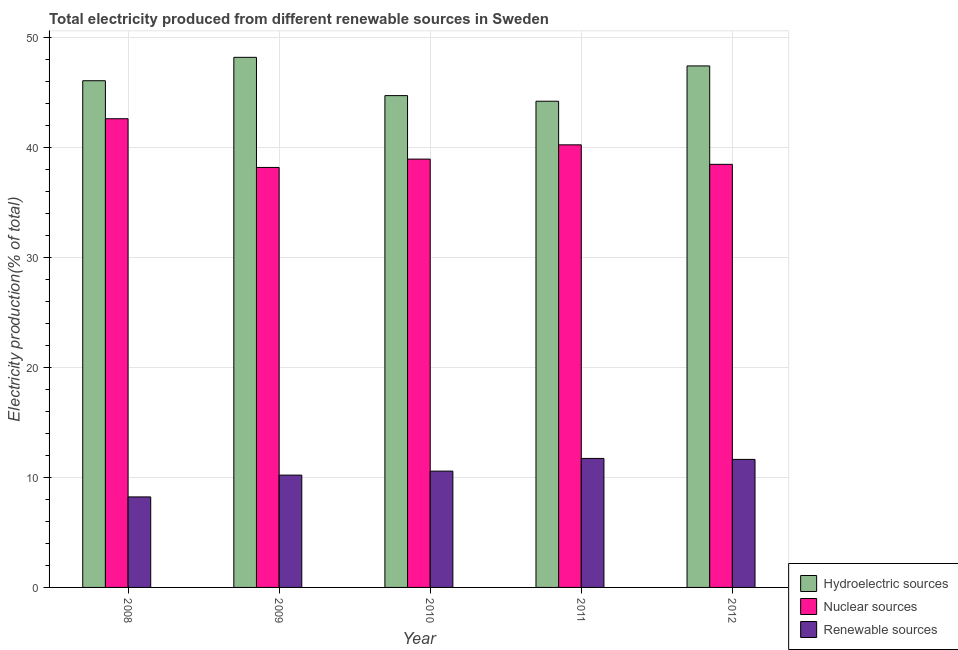Are the number of bars on each tick of the X-axis equal?
Give a very brief answer. Yes. How many bars are there on the 4th tick from the right?
Your answer should be compact. 3. What is the percentage of electricity produced by renewable sources in 2009?
Ensure brevity in your answer.  10.21. Across all years, what is the maximum percentage of electricity produced by hydroelectric sources?
Offer a terse response. 48.21. Across all years, what is the minimum percentage of electricity produced by hydroelectric sources?
Your answer should be very brief. 44.21. In which year was the percentage of electricity produced by renewable sources minimum?
Provide a succinct answer. 2008. What is the total percentage of electricity produced by nuclear sources in the graph?
Your response must be concise. 198.49. What is the difference between the percentage of electricity produced by hydroelectric sources in 2008 and that in 2010?
Provide a succinct answer. 1.35. What is the difference between the percentage of electricity produced by nuclear sources in 2010 and the percentage of electricity produced by hydroelectric sources in 2012?
Give a very brief answer. 0.48. What is the average percentage of electricity produced by renewable sources per year?
Make the answer very short. 10.48. In the year 2011, what is the difference between the percentage of electricity produced by nuclear sources and percentage of electricity produced by renewable sources?
Your answer should be very brief. 0. What is the ratio of the percentage of electricity produced by renewable sources in 2009 to that in 2011?
Offer a terse response. 0.87. What is the difference between the highest and the second highest percentage of electricity produced by hydroelectric sources?
Give a very brief answer. 0.78. What is the difference between the highest and the lowest percentage of electricity produced by renewable sources?
Offer a very short reply. 3.5. In how many years, is the percentage of electricity produced by hydroelectric sources greater than the average percentage of electricity produced by hydroelectric sources taken over all years?
Make the answer very short. 2. Is the sum of the percentage of electricity produced by nuclear sources in 2009 and 2010 greater than the maximum percentage of electricity produced by hydroelectric sources across all years?
Make the answer very short. Yes. What does the 1st bar from the left in 2010 represents?
Your response must be concise. Hydroelectric sources. What does the 2nd bar from the right in 2009 represents?
Your answer should be compact. Nuclear sources. Is it the case that in every year, the sum of the percentage of electricity produced by hydroelectric sources and percentage of electricity produced by nuclear sources is greater than the percentage of electricity produced by renewable sources?
Your answer should be very brief. Yes. Are all the bars in the graph horizontal?
Provide a succinct answer. No. How many years are there in the graph?
Offer a terse response. 5. What is the difference between two consecutive major ticks on the Y-axis?
Offer a very short reply. 10. Are the values on the major ticks of Y-axis written in scientific E-notation?
Offer a very short reply. No. Does the graph contain any zero values?
Provide a short and direct response. No. Where does the legend appear in the graph?
Your answer should be compact. Bottom right. How are the legend labels stacked?
Offer a very short reply. Vertical. What is the title of the graph?
Offer a very short reply. Total electricity produced from different renewable sources in Sweden. Does "Refusal of sex" appear as one of the legend labels in the graph?
Offer a very short reply. No. What is the label or title of the Y-axis?
Provide a short and direct response. Electricity production(% of total). What is the Electricity production(% of total) of Hydroelectric sources in 2008?
Ensure brevity in your answer.  46.08. What is the Electricity production(% of total) of Nuclear sources in 2008?
Provide a short and direct response. 42.62. What is the Electricity production(% of total) of Renewable sources in 2008?
Provide a succinct answer. 8.23. What is the Electricity production(% of total) in Hydroelectric sources in 2009?
Your answer should be compact. 48.21. What is the Electricity production(% of total) of Nuclear sources in 2009?
Give a very brief answer. 38.19. What is the Electricity production(% of total) in Renewable sources in 2009?
Give a very brief answer. 10.21. What is the Electricity production(% of total) of Hydroelectric sources in 2010?
Your response must be concise. 44.72. What is the Electricity production(% of total) in Nuclear sources in 2010?
Provide a succinct answer. 38.95. What is the Electricity production(% of total) in Renewable sources in 2010?
Your response must be concise. 10.58. What is the Electricity production(% of total) of Hydroelectric sources in 2011?
Give a very brief answer. 44.21. What is the Electricity production(% of total) of Nuclear sources in 2011?
Make the answer very short. 40.25. What is the Electricity production(% of total) in Renewable sources in 2011?
Ensure brevity in your answer.  11.73. What is the Electricity production(% of total) in Hydroelectric sources in 2012?
Offer a terse response. 47.42. What is the Electricity production(% of total) in Nuclear sources in 2012?
Ensure brevity in your answer.  38.48. What is the Electricity production(% of total) of Renewable sources in 2012?
Ensure brevity in your answer.  11.64. Across all years, what is the maximum Electricity production(% of total) of Hydroelectric sources?
Keep it short and to the point. 48.21. Across all years, what is the maximum Electricity production(% of total) of Nuclear sources?
Ensure brevity in your answer.  42.62. Across all years, what is the maximum Electricity production(% of total) in Renewable sources?
Your answer should be very brief. 11.73. Across all years, what is the minimum Electricity production(% of total) in Hydroelectric sources?
Provide a succinct answer. 44.21. Across all years, what is the minimum Electricity production(% of total) in Nuclear sources?
Provide a short and direct response. 38.19. Across all years, what is the minimum Electricity production(% of total) of Renewable sources?
Provide a succinct answer. 8.23. What is the total Electricity production(% of total) of Hydroelectric sources in the graph?
Ensure brevity in your answer.  230.65. What is the total Electricity production(% of total) in Nuclear sources in the graph?
Keep it short and to the point. 198.49. What is the total Electricity production(% of total) of Renewable sources in the graph?
Your response must be concise. 52.39. What is the difference between the Electricity production(% of total) of Hydroelectric sources in 2008 and that in 2009?
Your answer should be very brief. -2.13. What is the difference between the Electricity production(% of total) of Nuclear sources in 2008 and that in 2009?
Ensure brevity in your answer.  4.43. What is the difference between the Electricity production(% of total) in Renewable sources in 2008 and that in 2009?
Provide a short and direct response. -1.98. What is the difference between the Electricity production(% of total) of Hydroelectric sources in 2008 and that in 2010?
Your answer should be compact. 1.35. What is the difference between the Electricity production(% of total) of Nuclear sources in 2008 and that in 2010?
Your answer should be very brief. 3.67. What is the difference between the Electricity production(% of total) in Renewable sources in 2008 and that in 2010?
Give a very brief answer. -2.35. What is the difference between the Electricity production(% of total) of Hydroelectric sources in 2008 and that in 2011?
Your response must be concise. 1.86. What is the difference between the Electricity production(% of total) in Nuclear sources in 2008 and that in 2011?
Provide a succinct answer. 2.37. What is the difference between the Electricity production(% of total) in Renewable sources in 2008 and that in 2011?
Your answer should be compact. -3.5. What is the difference between the Electricity production(% of total) of Hydroelectric sources in 2008 and that in 2012?
Provide a short and direct response. -1.35. What is the difference between the Electricity production(% of total) in Nuclear sources in 2008 and that in 2012?
Your answer should be compact. 4.15. What is the difference between the Electricity production(% of total) of Renewable sources in 2008 and that in 2012?
Ensure brevity in your answer.  -3.41. What is the difference between the Electricity production(% of total) in Hydroelectric sources in 2009 and that in 2010?
Provide a short and direct response. 3.48. What is the difference between the Electricity production(% of total) in Nuclear sources in 2009 and that in 2010?
Your answer should be compact. -0.76. What is the difference between the Electricity production(% of total) in Renewable sources in 2009 and that in 2010?
Offer a very short reply. -0.36. What is the difference between the Electricity production(% of total) of Hydroelectric sources in 2009 and that in 2011?
Provide a short and direct response. 3.99. What is the difference between the Electricity production(% of total) in Nuclear sources in 2009 and that in 2011?
Ensure brevity in your answer.  -2.06. What is the difference between the Electricity production(% of total) of Renewable sources in 2009 and that in 2011?
Ensure brevity in your answer.  -1.52. What is the difference between the Electricity production(% of total) of Hydroelectric sources in 2009 and that in 2012?
Provide a short and direct response. 0.78. What is the difference between the Electricity production(% of total) in Nuclear sources in 2009 and that in 2012?
Your response must be concise. -0.28. What is the difference between the Electricity production(% of total) of Renewable sources in 2009 and that in 2012?
Your answer should be compact. -1.43. What is the difference between the Electricity production(% of total) in Hydroelectric sources in 2010 and that in 2011?
Keep it short and to the point. 0.51. What is the difference between the Electricity production(% of total) in Nuclear sources in 2010 and that in 2011?
Your response must be concise. -1.3. What is the difference between the Electricity production(% of total) in Renewable sources in 2010 and that in 2011?
Make the answer very short. -1.15. What is the difference between the Electricity production(% of total) of Hydroelectric sources in 2010 and that in 2012?
Ensure brevity in your answer.  -2.7. What is the difference between the Electricity production(% of total) in Nuclear sources in 2010 and that in 2012?
Keep it short and to the point. 0.48. What is the difference between the Electricity production(% of total) of Renewable sources in 2010 and that in 2012?
Your answer should be very brief. -1.07. What is the difference between the Electricity production(% of total) of Hydroelectric sources in 2011 and that in 2012?
Provide a short and direct response. -3.21. What is the difference between the Electricity production(% of total) of Nuclear sources in 2011 and that in 2012?
Offer a terse response. 1.77. What is the difference between the Electricity production(% of total) in Renewable sources in 2011 and that in 2012?
Offer a very short reply. 0.09. What is the difference between the Electricity production(% of total) of Hydroelectric sources in 2008 and the Electricity production(% of total) of Nuclear sources in 2009?
Provide a short and direct response. 7.89. What is the difference between the Electricity production(% of total) of Hydroelectric sources in 2008 and the Electricity production(% of total) of Renewable sources in 2009?
Provide a succinct answer. 35.87. What is the difference between the Electricity production(% of total) in Nuclear sources in 2008 and the Electricity production(% of total) in Renewable sources in 2009?
Make the answer very short. 32.41. What is the difference between the Electricity production(% of total) of Hydroelectric sources in 2008 and the Electricity production(% of total) of Nuclear sources in 2010?
Offer a very short reply. 7.13. What is the difference between the Electricity production(% of total) of Hydroelectric sources in 2008 and the Electricity production(% of total) of Renewable sources in 2010?
Offer a terse response. 35.5. What is the difference between the Electricity production(% of total) in Nuclear sources in 2008 and the Electricity production(% of total) in Renewable sources in 2010?
Ensure brevity in your answer.  32.05. What is the difference between the Electricity production(% of total) of Hydroelectric sources in 2008 and the Electricity production(% of total) of Nuclear sources in 2011?
Keep it short and to the point. 5.83. What is the difference between the Electricity production(% of total) of Hydroelectric sources in 2008 and the Electricity production(% of total) of Renewable sources in 2011?
Offer a very short reply. 34.35. What is the difference between the Electricity production(% of total) of Nuclear sources in 2008 and the Electricity production(% of total) of Renewable sources in 2011?
Offer a very short reply. 30.89. What is the difference between the Electricity production(% of total) of Hydroelectric sources in 2008 and the Electricity production(% of total) of Nuclear sources in 2012?
Your answer should be compact. 7.6. What is the difference between the Electricity production(% of total) of Hydroelectric sources in 2008 and the Electricity production(% of total) of Renewable sources in 2012?
Provide a succinct answer. 34.44. What is the difference between the Electricity production(% of total) in Nuclear sources in 2008 and the Electricity production(% of total) in Renewable sources in 2012?
Your answer should be compact. 30.98. What is the difference between the Electricity production(% of total) of Hydroelectric sources in 2009 and the Electricity production(% of total) of Nuclear sources in 2010?
Your answer should be compact. 9.25. What is the difference between the Electricity production(% of total) of Hydroelectric sources in 2009 and the Electricity production(% of total) of Renewable sources in 2010?
Ensure brevity in your answer.  37.63. What is the difference between the Electricity production(% of total) of Nuclear sources in 2009 and the Electricity production(% of total) of Renewable sources in 2010?
Offer a very short reply. 27.62. What is the difference between the Electricity production(% of total) of Hydroelectric sources in 2009 and the Electricity production(% of total) of Nuclear sources in 2011?
Your answer should be compact. 7.96. What is the difference between the Electricity production(% of total) in Hydroelectric sources in 2009 and the Electricity production(% of total) in Renewable sources in 2011?
Offer a very short reply. 36.48. What is the difference between the Electricity production(% of total) of Nuclear sources in 2009 and the Electricity production(% of total) of Renewable sources in 2011?
Provide a short and direct response. 26.46. What is the difference between the Electricity production(% of total) in Hydroelectric sources in 2009 and the Electricity production(% of total) in Nuclear sources in 2012?
Keep it short and to the point. 9.73. What is the difference between the Electricity production(% of total) in Hydroelectric sources in 2009 and the Electricity production(% of total) in Renewable sources in 2012?
Offer a terse response. 36.56. What is the difference between the Electricity production(% of total) in Nuclear sources in 2009 and the Electricity production(% of total) in Renewable sources in 2012?
Provide a succinct answer. 26.55. What is the difference between the Electricity production(% of total) in Hydroelectric sources in 2010 and the Electricity production(% of total) in Nuclear sources in 2011?
Keep it short and to the point. 4.48. What is the difference between the Electricity production(% of total) of Hydroelectric sources in 2010 and the Electricity production(% of total) of Renewable sources in 2011?
Provide a short and direct response. 32.99. What is the difference between the Electricity production(% of total) in Nuclear sources in 2010 and the Electricity production(% of total) in Renewable sources in 2011?
Keep it short and to the point. 27.22. What is the difference between the Electricity production(% of total) of Hydroelectric sources in 2010 and the Electricity production(% of total) of Nuclear sources in 2012?
Provide a short and direct response. 6.25. What is the difference between the Electricity production(% of total) in Hydroelectric sources in 2010 and the Electricity production(% of total) in Renewable sources in 2012?
Provide a short and direct response. 33.08. What is the difference between the Electricity production(% of total) in Nuclear sources in 2010 and the Electricity production(% of total) in Renewable sources in 2012?
Your response must be concise. 27.31. What is the difference between the Electricity production(% of total) of Hydroelectric sources in 2011 and the Electricity production(% of total) of Nuclear sources in 2012?
Make the answer very short. 5.74. What is the difference between the Electricity production(% of total) in Hydroelectric sources in 2011 and the Electricity production(% of total) in Renewable sources in 2012?
Your answer should be very brief. 32.57. What is the difference between the Electricity production(% of total) of Nuclear sources in 2011 and the Electricity production(% of total) of Renewable sources in 2012?
Make the answer very short. 28.61. What is the average Electricity production(% of total) of Hydroelectric sources per year?
Offer a terse response. 46.13. What is the average Electricity production(% of total) in Nuclear sources per year?
Your answer should be compact. 39.7. What is the average Electricity production(% of total) in Renewable sources per year?
Keep it short and to the point. 10.48. In the year 2008, what is the difference between the Electricity production(% of total) of Hydroelectric sources and Electricity production(% of total) of Nuclear sources?
Offer a very short reply. 3.46. In the year 2008, what is the difference between the Electricity production(% of total) of Hydroelectric sources and Electricity production(% of total) of Renewable sources?
Your answer should be compact. 37.85. In the year 2008, what is the difference between the Electricity production(% of total) in Nuclear sources and Electricity production(% of total) in Renewable sources?
Give a very brief answer. 34.39. In the year 2009, what is the difference between the Electricity production(% of total) of Hydroelectric sources and Electricity production(% of total) of Nuclear sources?
Give a very brief answer. 10.01. In the year 2009, what is the difference between the Electricity production(% of total) of Hydroelectric sources and Electricity production(% of total) of Renewable sources?
Provide a succinct answer. 37.99. In the year 2009, what is the difference between the Electricity production(% of total) in Nuclear sources and Electricity production(% of total) in Renewable sources?
Provide a succinct answer. 27.98. In the year 2010, what is the difference between the Electricity production(% of total) of Hydroelectric sources and Electricity production(% of total) of Nuclear sources?
Give a very brief answer. 5.77. In the year 2010, what is the difference between the Electricity production(% of total) in Hydroelectric sources and Electricity production(% of total) in Renewable sources?
Provide a succinct answer. 34.15. In the year 2010, what is the difference between the Electricity production(% of total) of Nuclear sources and Electricity production(% of total) of Renewable sources?
Your answer should be compact. 28.37. In the year 2011, what is the difference between the Electricity production(% of total) of Hydroelectric sources and Electricity production(% of total) of Nuclear sources?
Offer a very short reply. 3.97. In the year 2011, what is the difference between the Electricity production(% of total) in Hydroelectric sources and Electricity production(% of total) in Renewable sources?
Your answer should be very brief. 32.48. In the year 2011, what is the difference between the Electricity production(% of total) of Nuclear sources and Electricity production(% of total) of Renewable sources?
Offer a very short reply. 28.52. In the year 2012, what is the difference between the Electricity production(% of total) in Hydroelectric sources and Electricity production(% of total) in Nuclear sources?
Offer a very short reply. 8.95. In the year 2012, what is the difference between the Electricity production(% of total) of Hydroelectric sources and Electricity production(% of total) of Renewable sources?
Your answer should be compact. 35.78. In the year 2012, what is the difference between the Electricity production(% of total) of Nuclear sources and Electricity production(% of total) of Renewable sources?
Offer a very short reply. 26.83. What is the ratio of the Electricity production(% of total) of Hydroelectric sources in 2008 to that in 2009?
Your response must be concise. 0.96. What is the ratio of the Electricity production(% of total) of Nuclear sources in 2008 to that in 2009?
Keep it short and to the point. 1.12. What is the ratio of the Electricity production(% of total) in Renewable sources in 2008 to that in 2009?
Make the answer very short. 0.81. What is the ratio of the Electricity production(% of total) in Hydroelectric sources in 2008 to that in 2010?
Your response must be concise. 1.03. What is the ratio of the Electricity production(% of total) of Nuclear sources in 2008 to that in 2010?
Your answer should be very brief. 1.09. What is the ratio of the Electricity production(% of total) in Renewable sources in 2008 to that in 2010?
Make the answer very short. 0.78. What is the ratio of the Electricity production(% of total) in Hydroelectric sources in 2008 to that in 2011?
Make the answer very short. 1.04. What is the ratio of the Electricity production(% of total) of Nuclear sources in 2008 to that in 2011?
Keep it short and to the point. 1.06. What is the ratio of the Electricity production(% of total) of Renewable sources in 2008 to that in 2011?
Your response must be concise. 0.7. What is the ratio of the Electricity production(% of total) of Hydroelectric sources in 2008 to that in 2012?
Keep it short and to the point. 0.97. What is the ratio of the Electricity production(% of total) of Nuclear sources in 2008 to that in 2012?
Keep it short and to the point. 1.11. What is the ratio of the Electricity production(% of total) of Renewable sources in 2008 to that in 2012?
Offer a terse response. 0.71. What is the ratio of the Electricity production(% of total) of Hydroelectric sources in 2009 to that in 2010?
Provide a succinct answer. 1.08. What is the ratio of the Electricity production(% of total) of Nuclear sources in 2009 to that in 2010?
Ensure brevity in your answer.  0.98. What is the ratio of the Electricity production(% of total) in Renewable sources in 2009 to that in 2010?
Offer a terse response. 0.97. What is the ratio of the Electricity production(% of total) in Hydroelectric sources in 2009 to that in 2011?
Your answer should be very brief. 1.09. What is the ratio of the Electricity production(% of total) of Nuclear sources in 2009 to that in 2011?
Give a very brief answer. 0.95. What is the ratio of the Electricity production(% of total) in Renewable sources in 2009 to that in 2011?
Make the answer very short. 0.87. What is the ratio of the Electricity production(% of total) of Hydroelectric sources in 2009 to that in 2012?
Ensure brevity in your answer.  1.02. What is the ratio of the Electricity production(% of total) of Renewable sources in 2009 to that in 2012?
Ensure brevity in your answer.  0.88. What is the ratio of the Electricity production(% of total) in Hydroelectric sources in 2010 to that in 2011?
Your answer should be very brief. 1.01. What is the ratio of the Electricity production(% of total) in Nuclear sources in 2010 to that in 2011?
Your answer should be very brief. 0.97. What is the ratio of the Electricity production(% of total) in Renewable sources in 2010 to that in 2011?
Offer a very short reply. 0.9. What is the ratio of the Electricity production(% of total) in Hydroelectric sources in 2010 to that in 2012?
Provide a succinct answer. 0.94. What is the ratio of the Electricity production(% of total) of Nuclear sources in 2010 to that in 2012?
Make the answer very short. 1.01. What is the ratio of the Electricity production(% of total) in Renewable sources in 2010 to that in 2012?
Ensure brevity in your answer.  0.91. What is the ratio of the Electricity production(% of total) of Hydroelectric sources in 2011 to that in 2012?
Your response must be concise. 0.93. What is the ratio of the Electricity production(% of total) of Nuclear sources in 2011 to that in 2012?
Keep it short and to the point. 1.05. What is the ratio of the Electricity production(% of total) of Renewable sources in 2011 to that in 2012?
Provide a succinct answer. 1.01. What is the difference between the highest and the second highest Electricity production(% of total) of Hydroelectric sources?
Offer a terse response. 0.78. What is the difference between the highest and the second highest Electricity production(% of total) of Nuclear sources?
Your answer should be very brief. 2.37. What is the difference between the highest and the second highest Electricity production(% of total) in Renewable sources?
Your answer should be compact. 0.09. What is the difference between the highest and the lowest Electricity production(% of total) in Hydroelectric sources?
Your answer should be compact. 3.99. What is the difference between the highest and the lowest Electricity production(% of total) in Nuclear sources?
Offer a terse response. 4.43. What is the difference between the highest and the lowest Electricity production(% of total) of Renewable sources?
Your response must be concise. 3.5. 